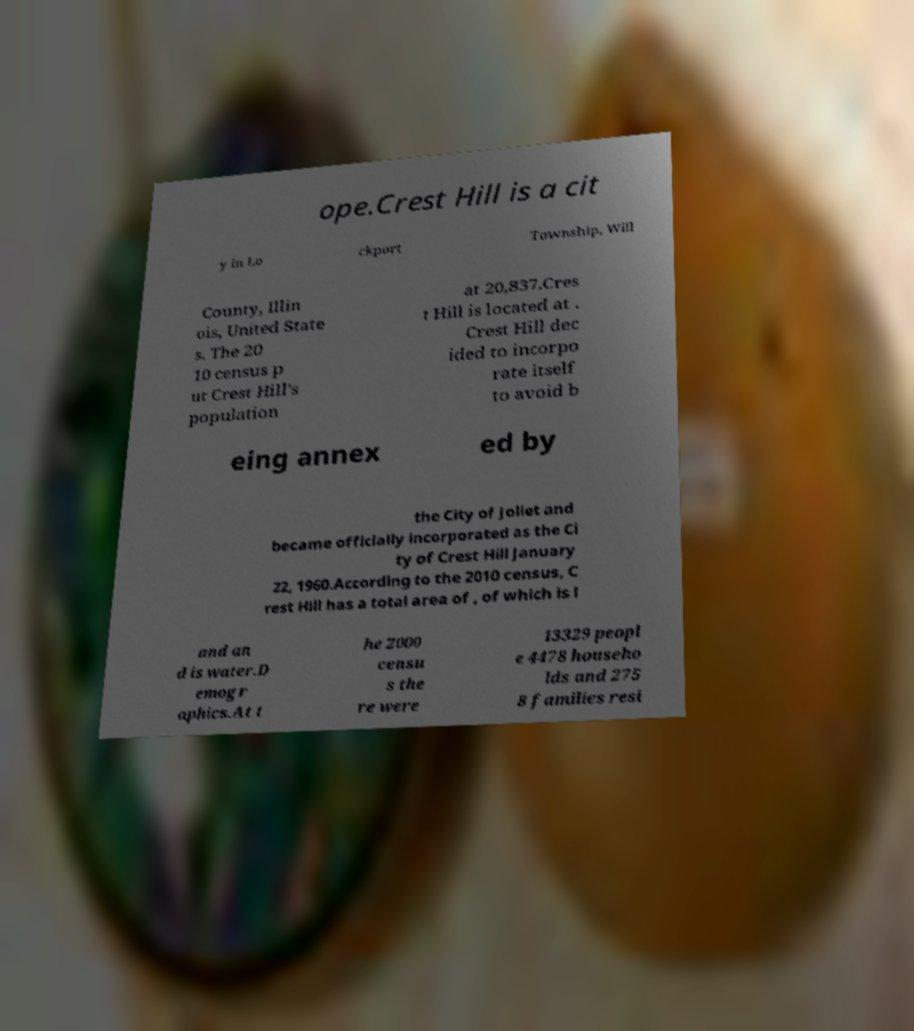Could you extract and type out the text from this image? ope.Crest Hill is a cit y in Lo ckport Township, Will County, Illin ois, United State s. The 20 10 census p ut Crest Hill's population at 20,837.Cres t Hill is located at . Crest Hill dec ided to incorpo rate itself to avoid b eing annex ed by the City of Joliet and became officially incorporated as the Ci ty of Crest Hill January 22, 1960.According to the 2010 census, C rest Hill has a total area of , of which is l and an d is water.D emogr aphics.At t he 2000 censu s the re were 13329 peopl e 4478 househo lds and 275 8 families resi 